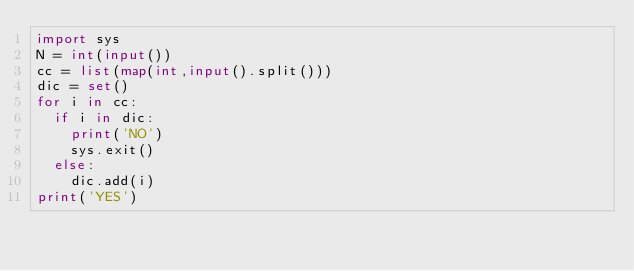Convert code to text. <code><loc_0><loc_0><loc_500><loc_500><_Python_>import sys
N = int(input())
cc = list(map(int,input().split()))
dic = set()
for i in cc:
  if i in dic:
    print('NO')
    sys.exit()
  else:
    dic.add(i)
print('YES')</code> 